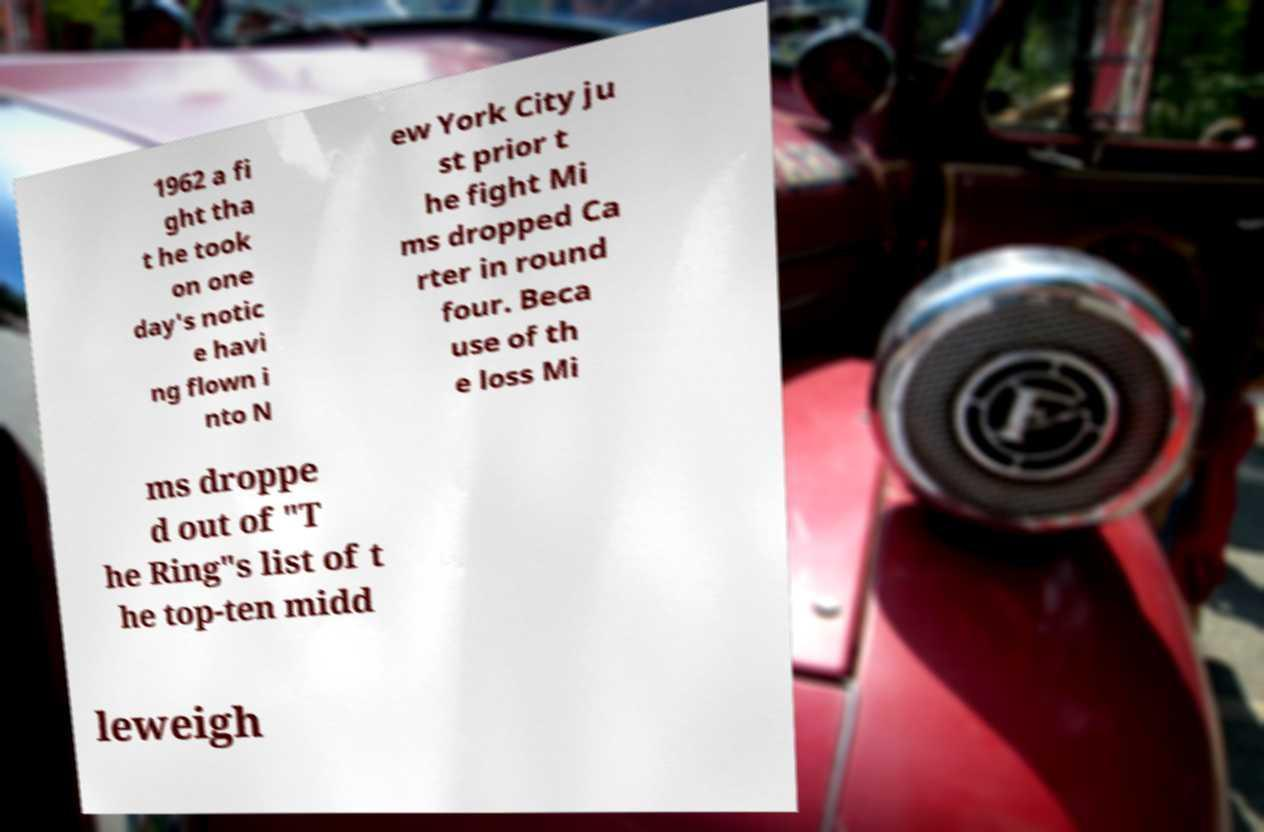What messages or text are displayed in this image? I need them in a readable, typed format. 1962 a fi ght tha t he took on one day's notic e havi ng flown i nto N ew York City ju st prior t he fight Mi ms dropped Ca rter in round four. Beca use of th e loss Mi ms droppe d out of "T he Ring"s list of t he top-ten midd leweigh 